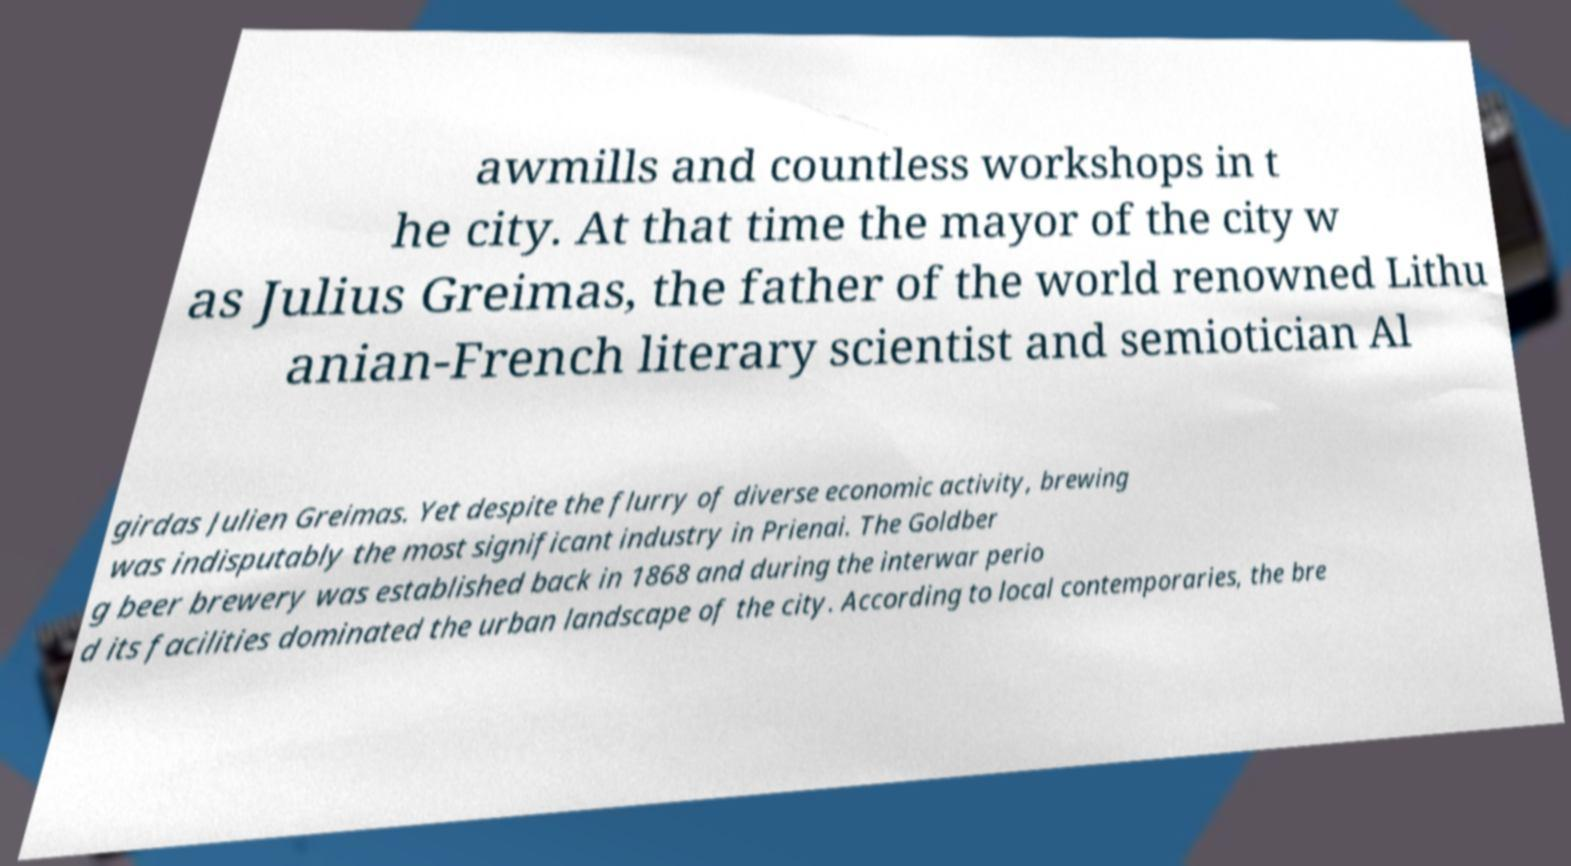There's text embedded in this image that I need extracted. Can you transcribe it verbatim? awmills and countless workshops in t he city. At that time the mayor of the city w as Julius Greimas, the father of the world renowned Lithu anian-French literary scientist and semiotician Al girdas Julien Greimas. Yet despite the flurry of diverse economic activity, brewing was indisputably the most significant industry in Prienai. The Goldber g beer brewery was established back in 1868 and during the interwar perio d its facilities dominated the urban landscape of the city. According to local contemporaries, the bre 